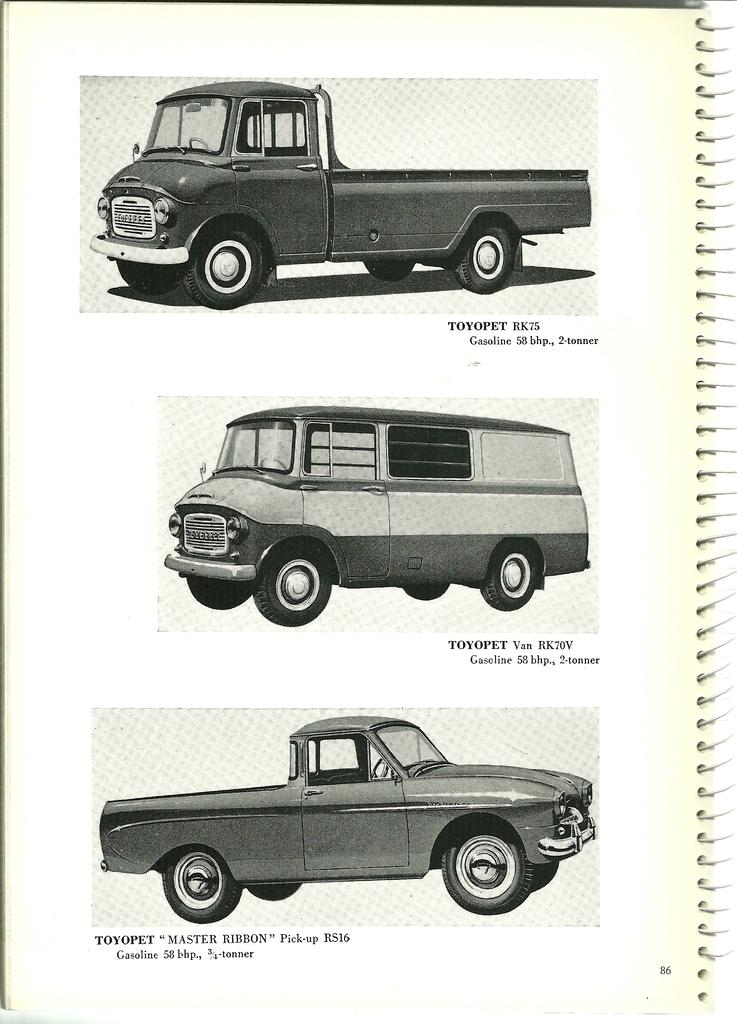How many vehicles are present in the image? There are three vehicles in the image. Can you describe the writing below each vehicle? Unfortunately, the facts provided do not give any information about the writing below each vehicle. What type of poison is being used by the family in the image? There is no family or poison present in the image. How many members are in the committee depicted in the image? There is no committee present in the image. 